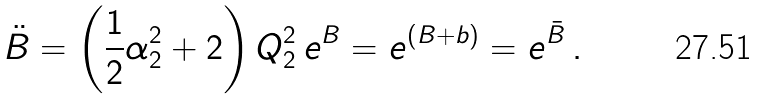Convert formula to latex. <formula><loc_0><loc_0><loc_500><loc_500>\ddot { B } = \left ( \frac { 1 } { 2 } \alpha _ { 2 } ^ { 2 } + 2 \right ) Q _ { 2 } ^ { 2 } \, e ^ { B } = e ^ { ( B + b ) } = e ^ { \bar { B } } \, .</formula> 